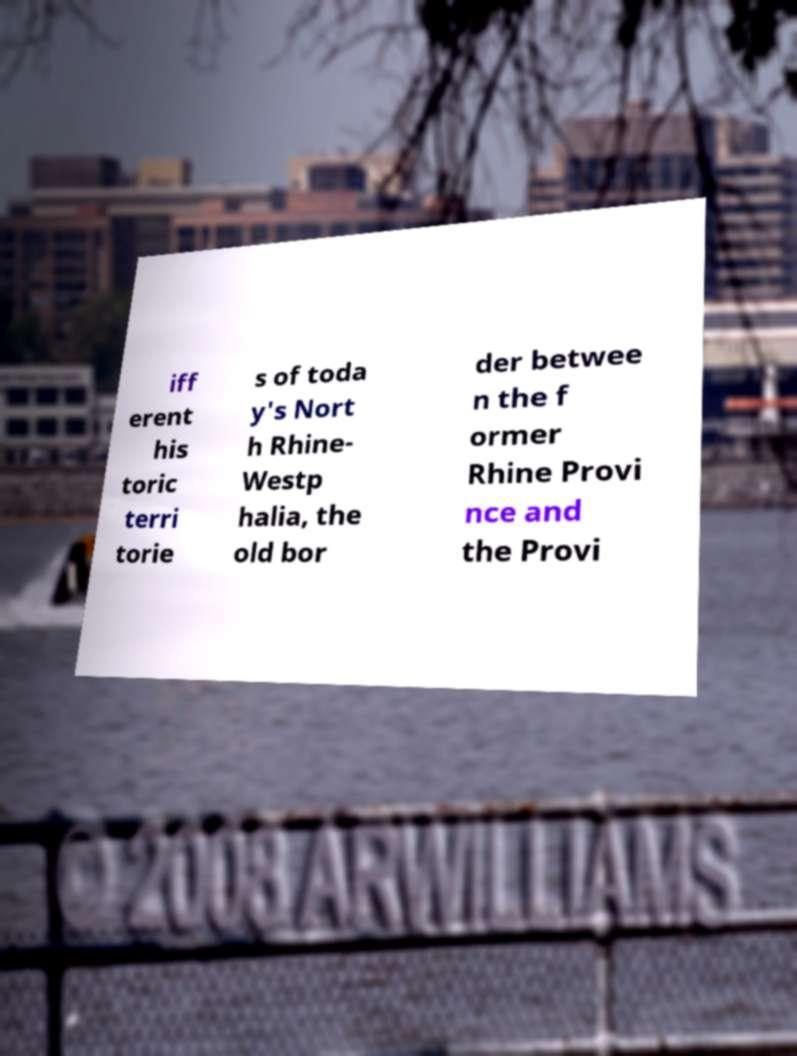What messages or text are displayed in this image? I need them in a readable, typed format. iff erent his toric terri torie s of toda y's Nort h Rhine- Westp halia, the old bor der betwee n the f ormer Rhine Provi nce and the Provi 